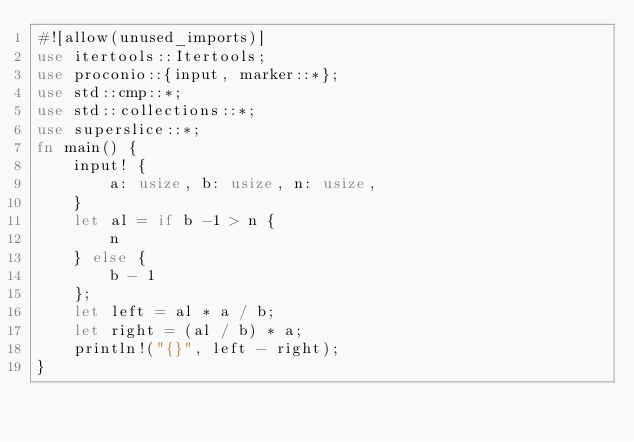Convert code to text. <code><loc_0><loc_0><loc_500><loc_500><_Rust_>#![allow(unused_imports)]
use itertools::Itertools;
use proconio::{input, marker::*};
use std::cmp::*;
use std::collections::*;
use superslice::*;
fn main() {
    input! {
        a: usize, b: usize, n: usize,
    }
    let al = if b -1 > n {
        n
    } else {
        b - 1
    };
    let left = al * a / b;
    let right = (al / b) * a;
    println!("{}", left - right);
}
</code> 